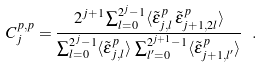Convert formula to latex. <formula><loc_0><loc_0><loc_500><loc_500>C _ { j } ^ { p , p } = \frac { 2 ^ { j + 1 } \sum _ { l = 0 } ^ { 2 ^ { j } - 1 } \langle \tilde { \epsilon } _ { j , l } ^ { p } \, \tilde { \epsilon } _ { j + 1 , 2 l } ^ { p } \rangle } { \sum _ { l = 0 } ^ { 2 ^ { j } - 1 } \langle \tilde { \epsilon } _ { j , l } ^ { p } \rangle \, \sum _ { l ^ { \prime } = 0 } ^ { 2 ^ { j + 1 } - 1 } \langle \tilde { \epsilon } _ { { j + 1 } , l ^ { \prime } } ^ { p } \rangle } \ .</formula> 